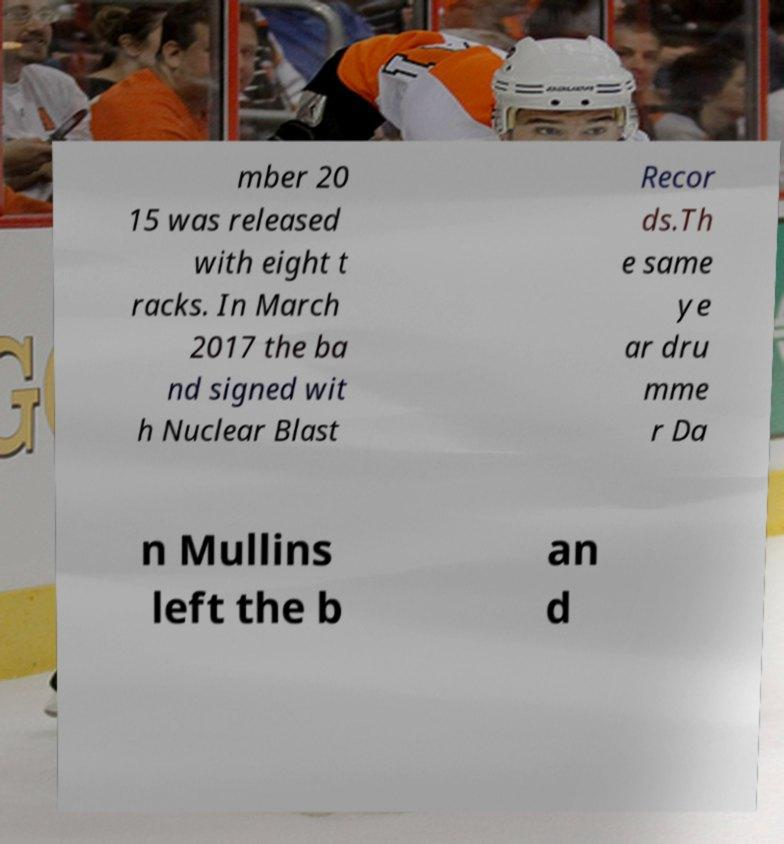Could you extract and type out the text from this image? mber 20 15 was released with eight t racks. In March 2017 the ba nd signed wit h Nuclear Blast Recor ds.Th e same ye ar dru mme r Da n Mullins left the b an d 